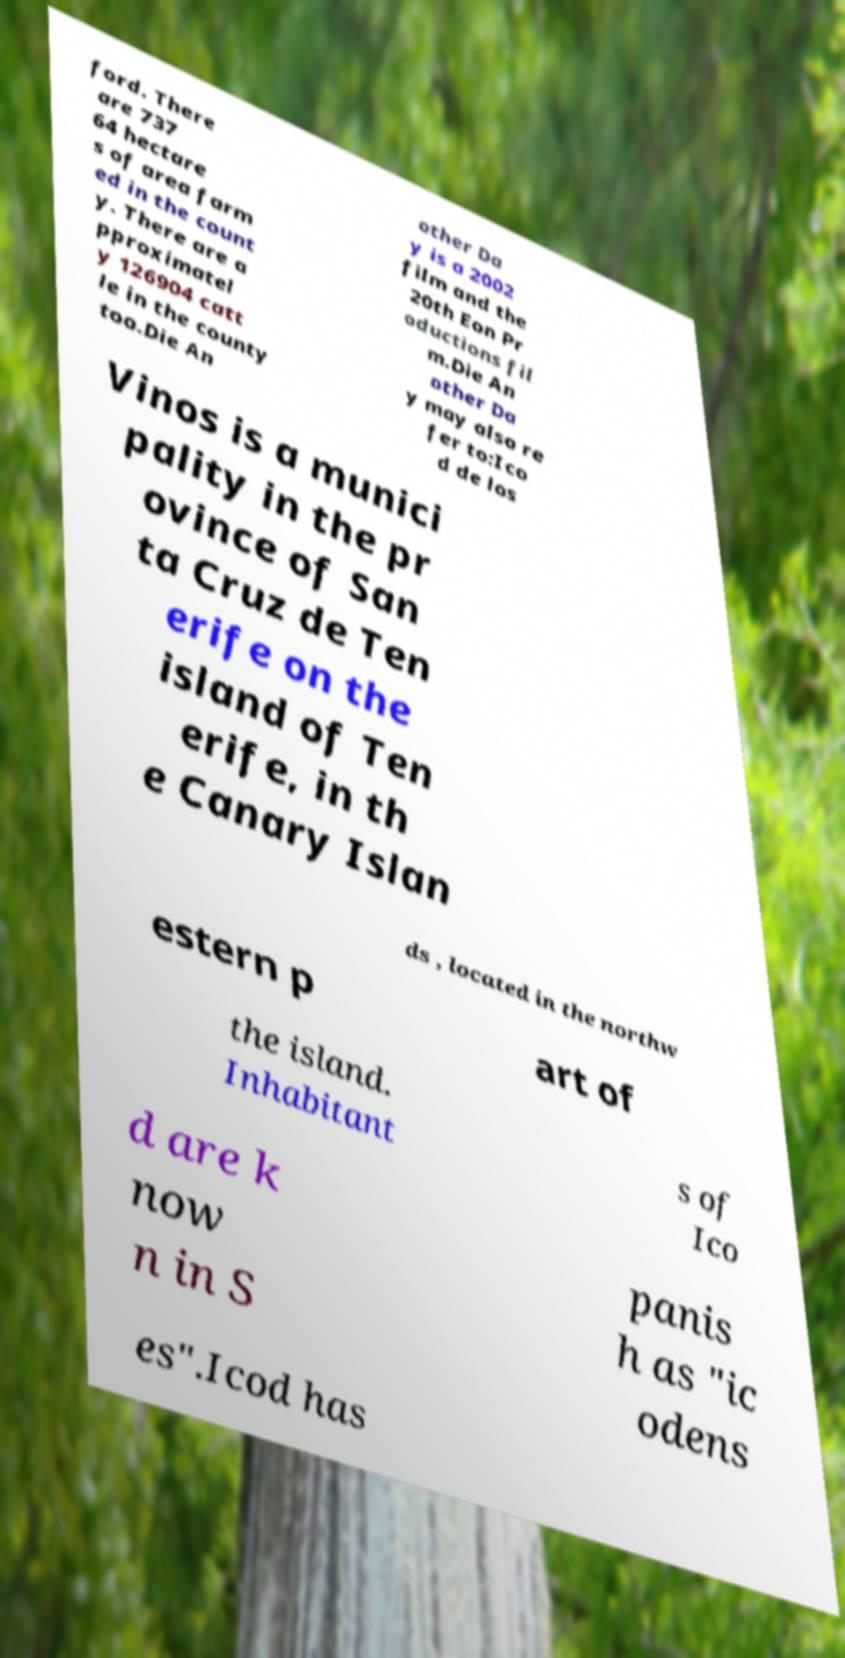What messages or text are displayed in this image? I need them in a readable, typed format. ford. There are 737 64 hectare s of area farm ed in the count y. There are a pproximatel y 126904 catt le in the county too.Die An other Da y is a 2002 film and the 20th Eon Pr oductions fil m.Die An other Da y may also re fer to:Ico d de los Vinos is a munici pality in the pr ovince of San ta Cruz de Ten erife on the island of Ten erife, in th e Canary Islan ds , located in the northw estern p art of the island. Inhabitant s of Ico d are k now n in S panis h as "ic odens es".Icod has 